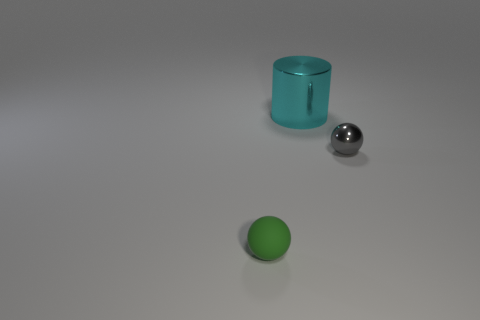What materials do these objects look like they are made of? Based on their appearance, the large silver sphere looks metallic, likely steel or chrome finish, the smaller green sphere could be plastic or rubber due to its matte finish, and the cyan cylinder has a glass-like appearance with a translucent quality, indicating it might be made of glass or a similar transparent material. 